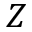Convert formula to latex. <formula><loc_0><loc_0><loc_500><loc_500>Z</formula> 